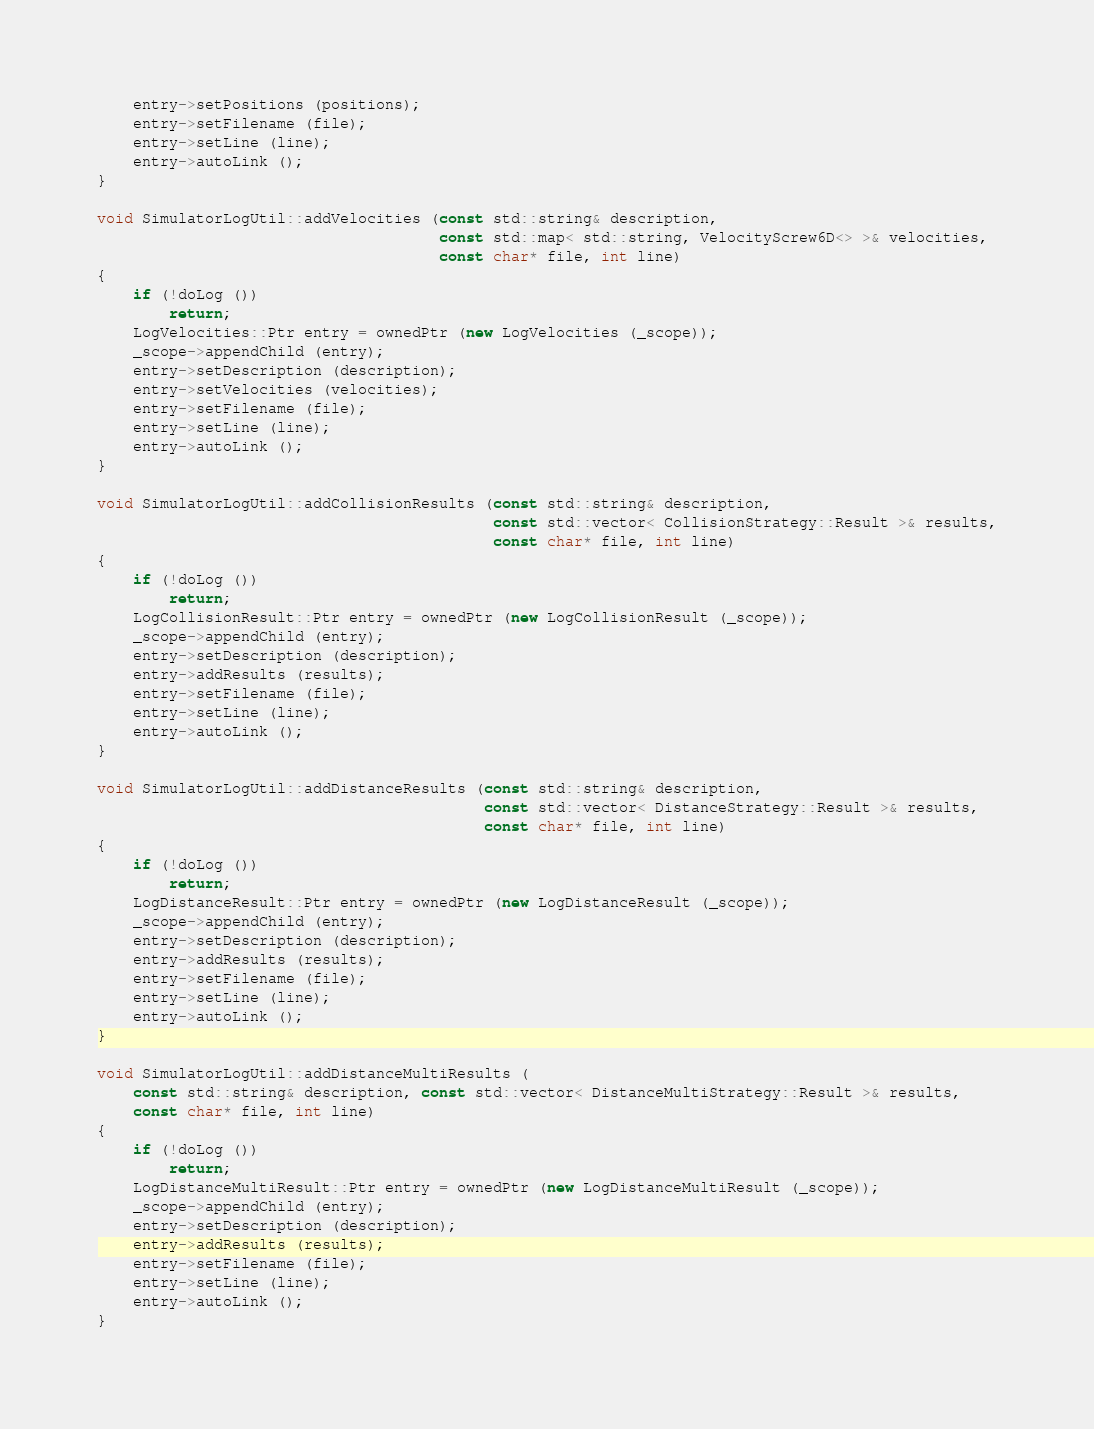Convert code to text. <code><loc_0><loc_0><loc_500><loc_500><_C++_>    entry->setPositions (positions);
    entry->setFilename (file);
    entry->setLine (line);
    entry->autoLink ();
}

void SimulatorLogUtil::addVelocities (const std::string& description,
                                      const std::map< std::string, VelocityScrew6D<> >& velocities,
                                      const char* file, int line)
{
    if (!doLog ())
        return;
    LogVelocities::Ptr entry = ownedPtr (new LogVelocities (_scope));
    _scope->appendChild (entry);
    entry->setDescription (description);
    entry->setVelocities (velocities);
    entry->setFilename (file);
    entry->setLine (line);
    entry->autoLink ();
}

void SimulatorLogUtil::addCollisionResults (const std::string& description,
                                            const std::vector< CollisionStrategy::Result >& results,
                                            const char* file, int line)
{
    if (!doLog ())
        return;
    LogCollisionResult::Ptr entry = ownedPtr (new LogCollisionResult (_scope));
    _scope->appendChild (entry);
    entry->setDescription (description);
    entry->addResults (results);
    entry->setFilename (file);
    entry->setLine (line);
    entry->autoLink ();
}

void SimulatorLogUtil::addDistanceResults (const std::string& description,
                                           const std::vector< DistanceStrategy::Result >& results,
                                           const char* file, int line)
{
    if (!doLog ())
        return;
    LogDistanceResult::Ptr entry = ownedPtr (new LogDistanceResult (_scope));
    _scope->appendChild (entry);
    entry->setDescription (description);
    entry->addResults (results);
    entry->setFilename (file);
    entry->setLine (line);
    entry->autoLink ();
}

void SimulatorLogUtil::addDistanceMultiResults (
    const std::string& description, const std::vector< DistanceMultiStrategy::Result >& results,
    const char* file, int line)
{
    if (!doLog ())
        return;
    LogDistanceMultiResult::Ptr entry = ownedPtr (new LogDistanceMultiResult (_scope));
    _scope->appendChild (entry);
    entry->setDescription (description);
    entry->addResults (results);
    entry->setFilename (file);
    entry->setLine (line);
    entry->autoLink ();
}
</code> 